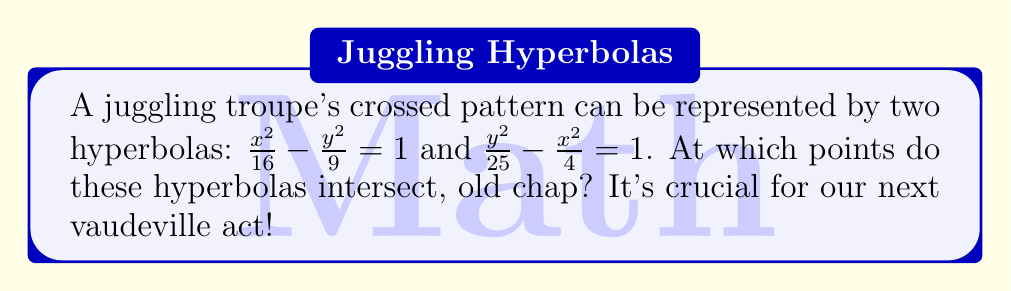Show me your answer to this math problem. Let's solve this step-by-step, like choreographing a perfect juggling routine:

1) We have two equations:
   $$\frac{x^2}{16} - \frac{y^2}{9} = 1 \quad \text{(Equation 1)}$$
   $$\frac{y^2}{25} - \frac{x^2}{4} = 1 \quad \text{(Equation 2)}$$

2) Multiply Equation 1 by 9 and Equation 2 by 25:
   $$\frac{9x^2}{16} - y^2 = 9 \quad \text{(Equation 3)}$$
   $$y^2 - \frac{25x^2}{4} = 25 \quad \text{(Equation 4)}$$

3) Add Equations 3 and 4:
   $$\frac{9x^2}{16} - \frac{25x^2}{4} = 34$$

4) Find a common denominator:
   $$\frac{9x^2}{16} - \frac{100x^2}{16} = 34$$
   $$-\frac{91x^2}{16} = 34$$

5) Solve for $x^2$:
   $$x^2 = -\frac{34 \cdot 16}{91} = -\frac{544}{91}$$

6) Take the square root:
   $$x = \pm \frac{4\sqrt{34}}{7\sqrt{13}}$$

7) Substitute this $x$ value into Equation 1 to find $y$:
   $$\frac{(\frac{4\sqrt{34}}{7\sqrt{13}})^2}{16} - \frac{y^2}{9} = 1$$
   $$\frac{16 \cdot 34}{49 \cdot 13 \cdot 16} - \frac{y^2}{9} = 1$$
   $$\frac{34}{49 \cdot 13} - \frac{y^2}{9} = 1$$
   $$\frac{y^2}{9} = \frac{34}{49 \cdot 13} - 1 = \frac{34 - 49 \cdot 13}{49 \cdot 13} = \frac{34 - 637}{637} = -\frac{603}{637}$$
   $$y^2 = -\frac{603 \cdot 9}{637} = -\frac{5427}{637}$$
   $$y = \pm \frac{3\sqrt{603}}{7\sqrt{13}}$$

Therefore, the intersection points are:
$$(\frac{4\sqrt{34}}{7\sqrt{13}}, \frac{3\sqrt{603}}{7\sqrt{13}}) \text{ and } (-\frac{4\sqrt{34}}{7\sqrt{13}}, -\frac{3\sqrt{603}}{7\sqrt{13}})$$
Answer: $(\pm\frac{4\sqrt{34}}{7\sqrt{13}}, \pm\frac{3\sqrt{603}}{7\sqrt{13}})$ 